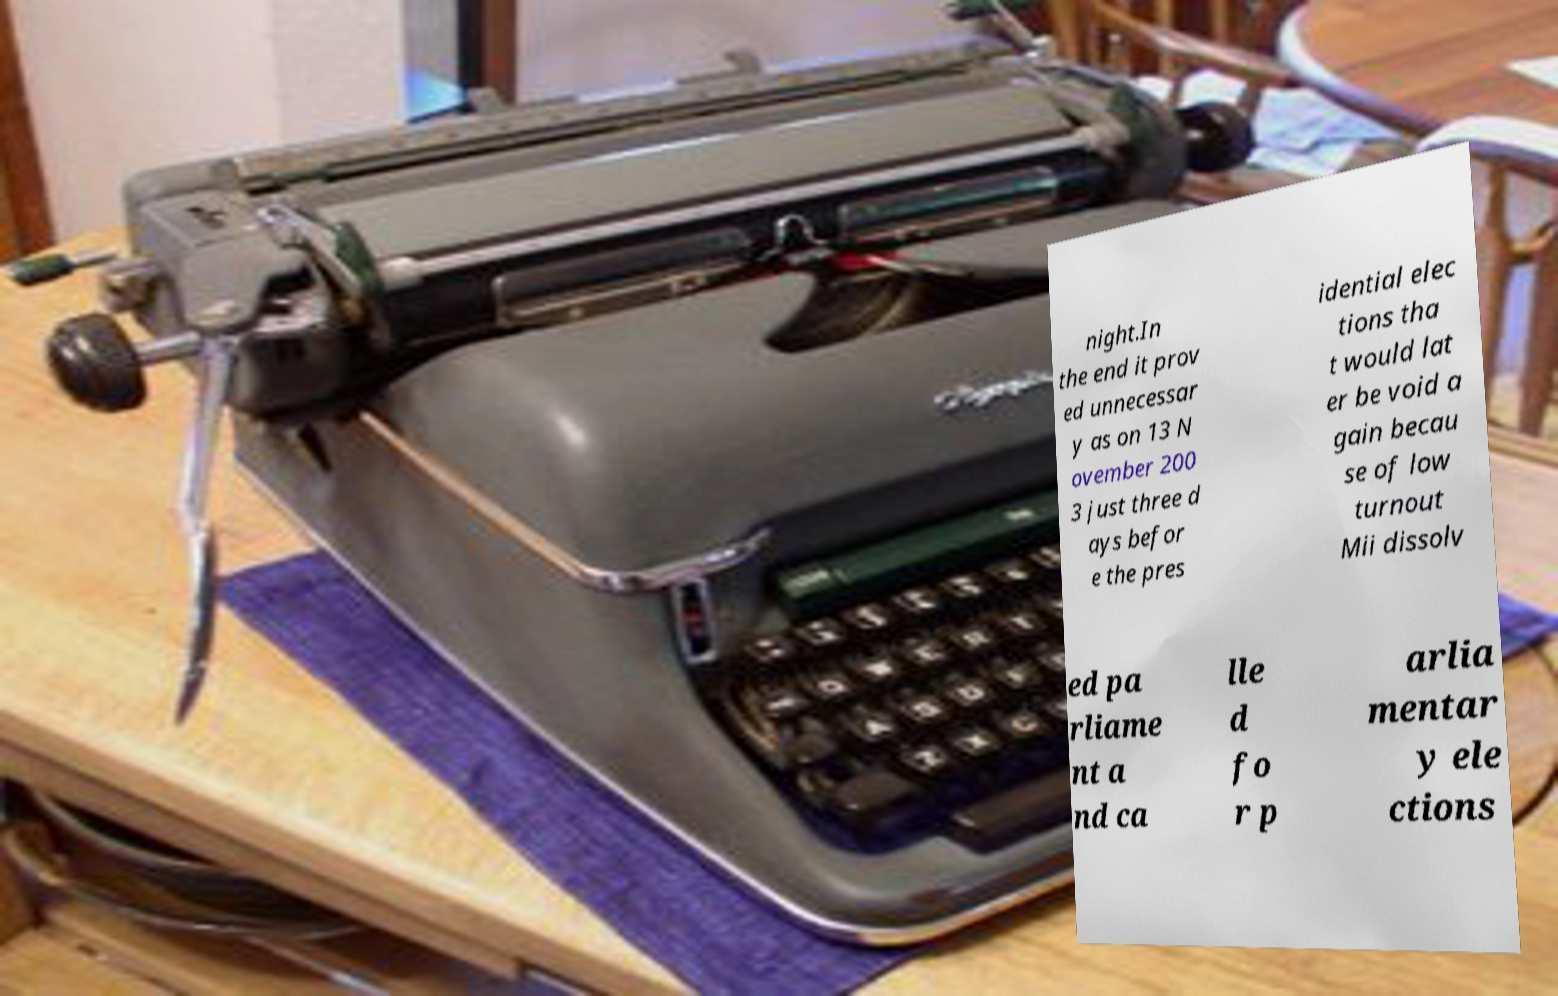For documentation purposes, I need the text within this image transcribed. Could you provide that? night.In the end it prov ed unnecessar y as on 13 N ovember 200 3 just three d ays befor e the pres idential elec tions tha t would lat er be void a gain becau se of low turnout Mii dissolv ed pa rliame nt a nd ca lle d fo r p arlia mentar y ele ctions 